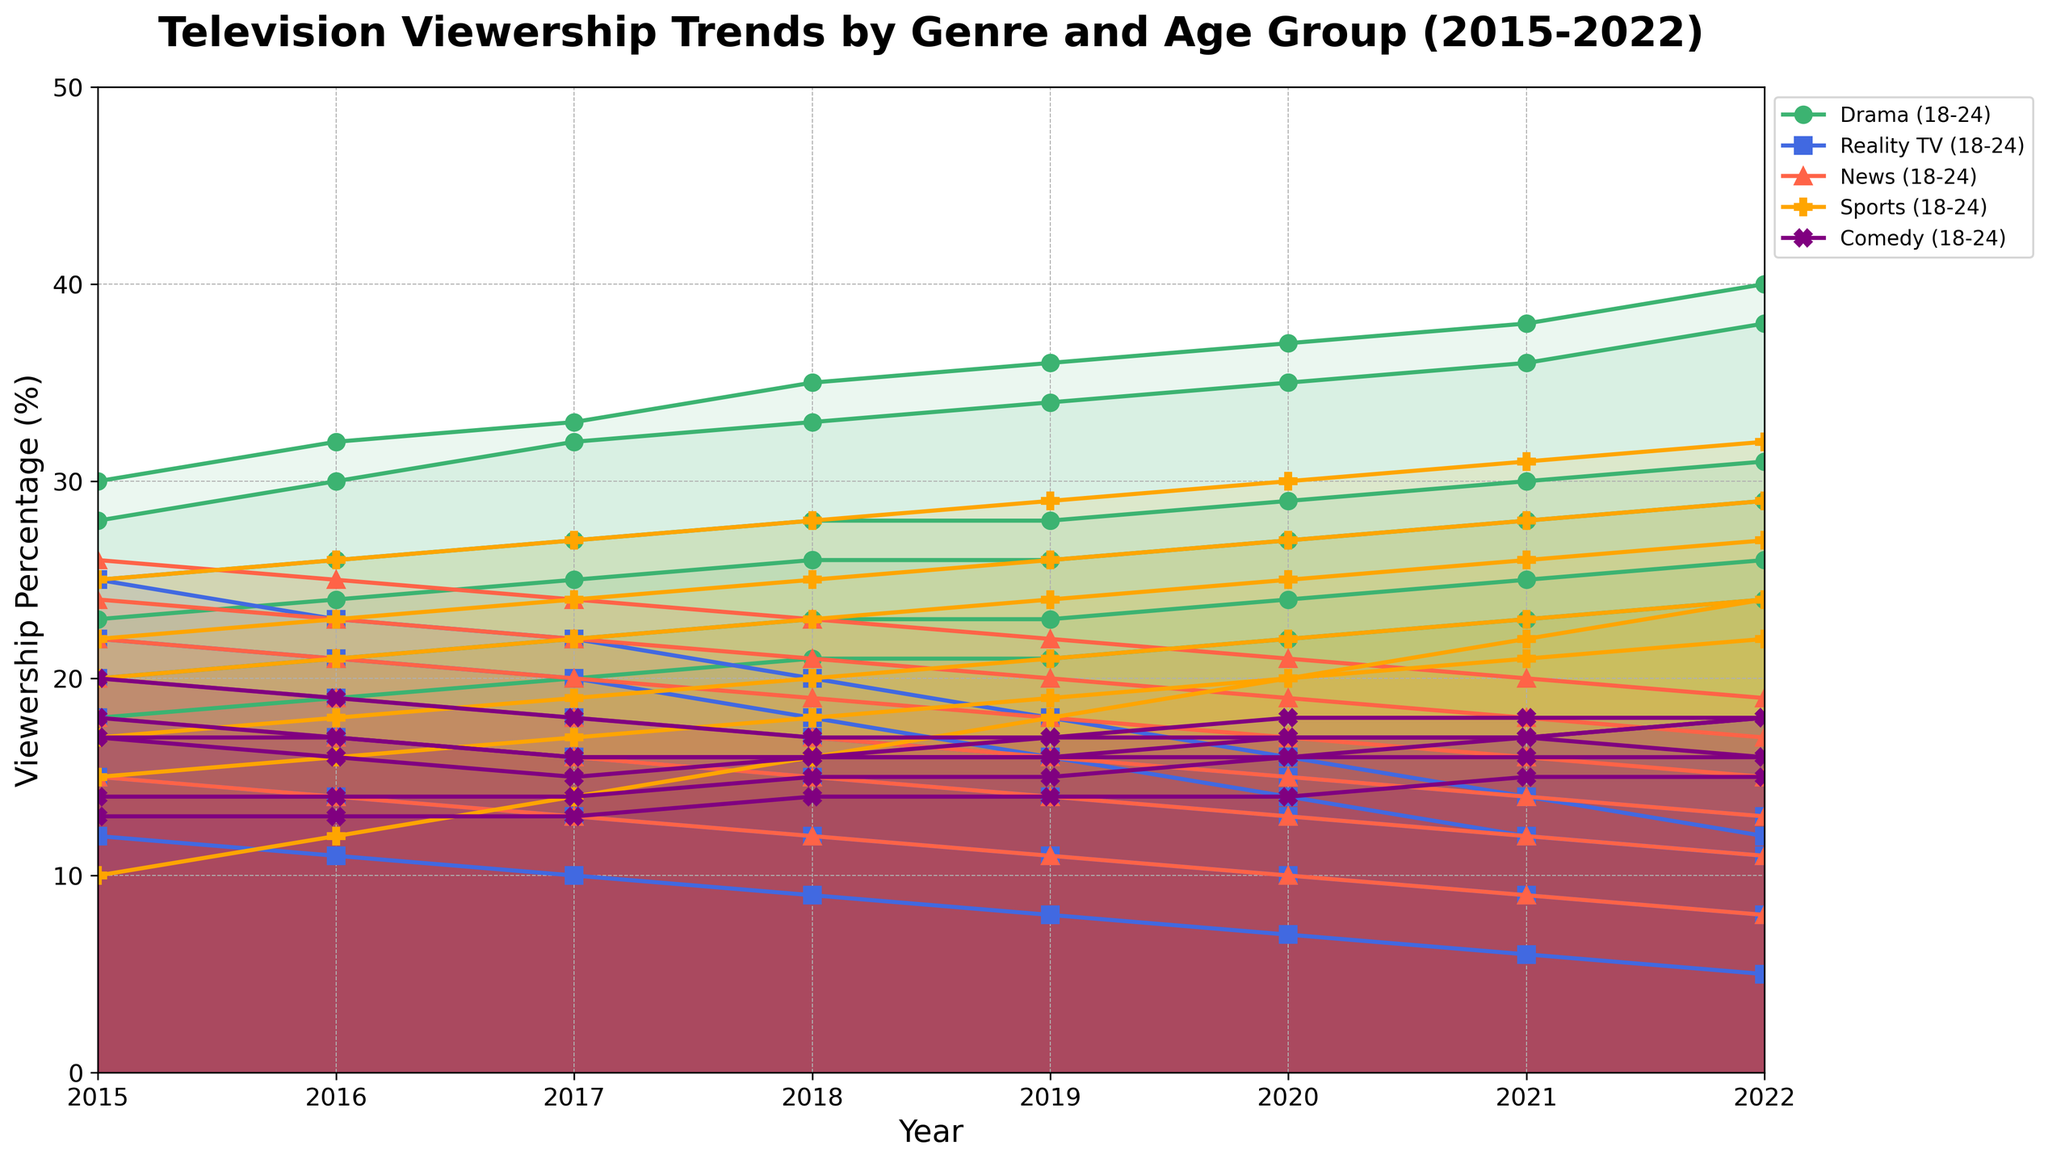Which age group shows the sharpest decline in Reality TV viewership from 2015 to 2022? To find the answer, examine the slope for the line representing Reality TV viewership for each age group. The 18-24 age group line shows the steepest decline from 25% in 2015 to 12% in 2022.
Answer: 18-24 Which genre has the highest viewership percentage across all age groups in 2022? Identify the highest point on the y-axis for each genre's line in 2022. Sports achieve the highest viewership percentage, reaching 32%.
Answer: Sports How does the viewership of Comedy change for the 25-34 age group from 2015 to 2022? Look at the Comedy line for the 25-34 age group. The viewership starts at 17% in 2015 and stabilizes at 18% in 2022.
Answer: Slightly increases In 2020, which genre has the closest viewership percentages between the 18-24 and 65+ age groups? Compare the 2020 viewership percentages for all genres between the 18-24 and 65+ age groups. News has the closest percentages with 10% for the 18-24 group and 21% for the 65+ group.
Answer: News Which age group has the highest viewership percentage for Drama in 2022? Refer to the height of the Drama lines in 2022 for each age group. The 18-24 age group tops at 40%.
Answer: 18-24 Between 2015 and 2022, which genre shows the most consistent viewership trend for the 35-44 age group? Examine the lines for the 35-44 age group. The Drama line shows a steady and consistent increase from 25% in 2015 to 31% in 2022.
Answer: Drama What is the difference in viewership percentage for News between the 55-64 and 65+ age groups in 2022? Check the y-axis positions of the News line for both age groups in 2022. The 55-64 age group is at 17% and the 65+ group is at 19%. The difference is
Answer: 2% Which age group experienced the greatest increase in Sports viewership from 2015 to 2022? Calculate the difference between the start and end points for the Sports line for each age group. The 65+ age group sees an increase from 25% in 2015 to 32% in 2022, the largest increment.
Answer: 65+ In which year did the 45-54 age group's Comedy viewership switch from decreasing to increasing? Analyze the trend of the Comedy line for the 45-54 age group. The viewership decreased until 2019 and began to increase after.
Answer: 2019 